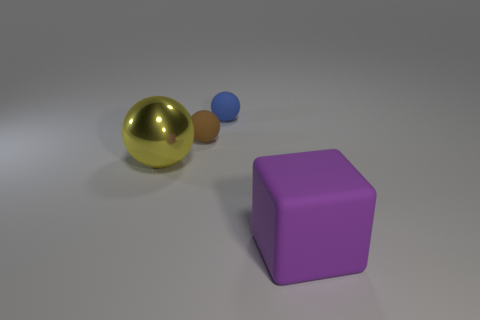Add 1 big gray metallic balls. How many objects exist? 5 Subtract all cubes. How many objects are left? 3 Subtract all large green cylinders. Subtract all small blue rubber spheres. How many objects are left? 3 Add 1 big rubber things. How many big rubber things are left? 2 Add 3 small blue rubber objects. How many small blue rubber objects exist? 4 Subtract 1 purple cubes. How many objects are left? 3 